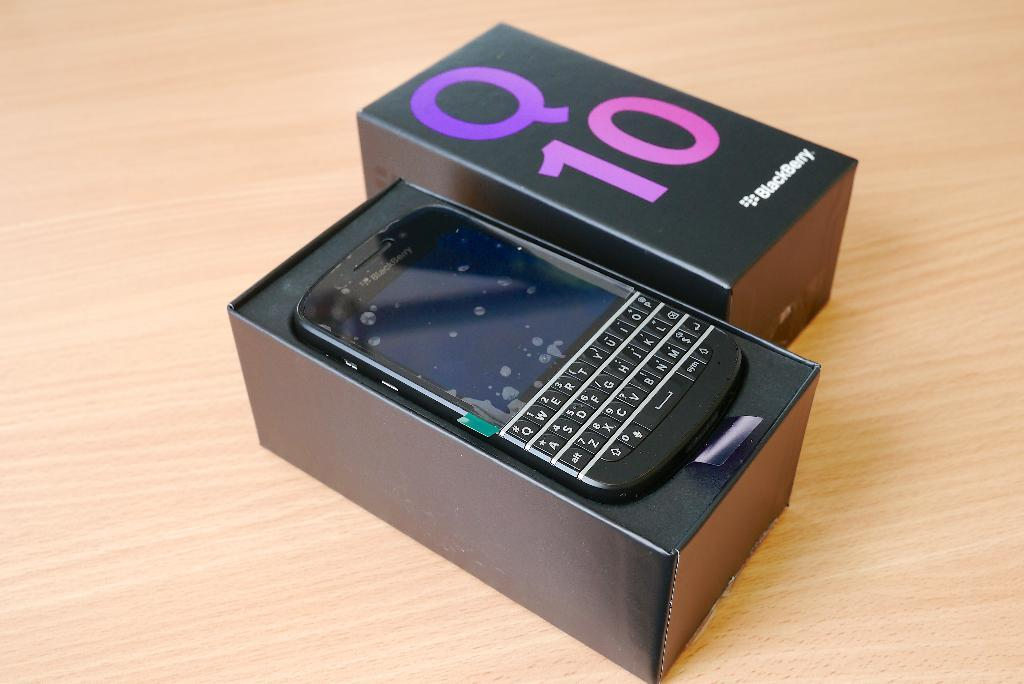<image>
Describe the image concisely. the blackberry q 10 is in the box on the table 